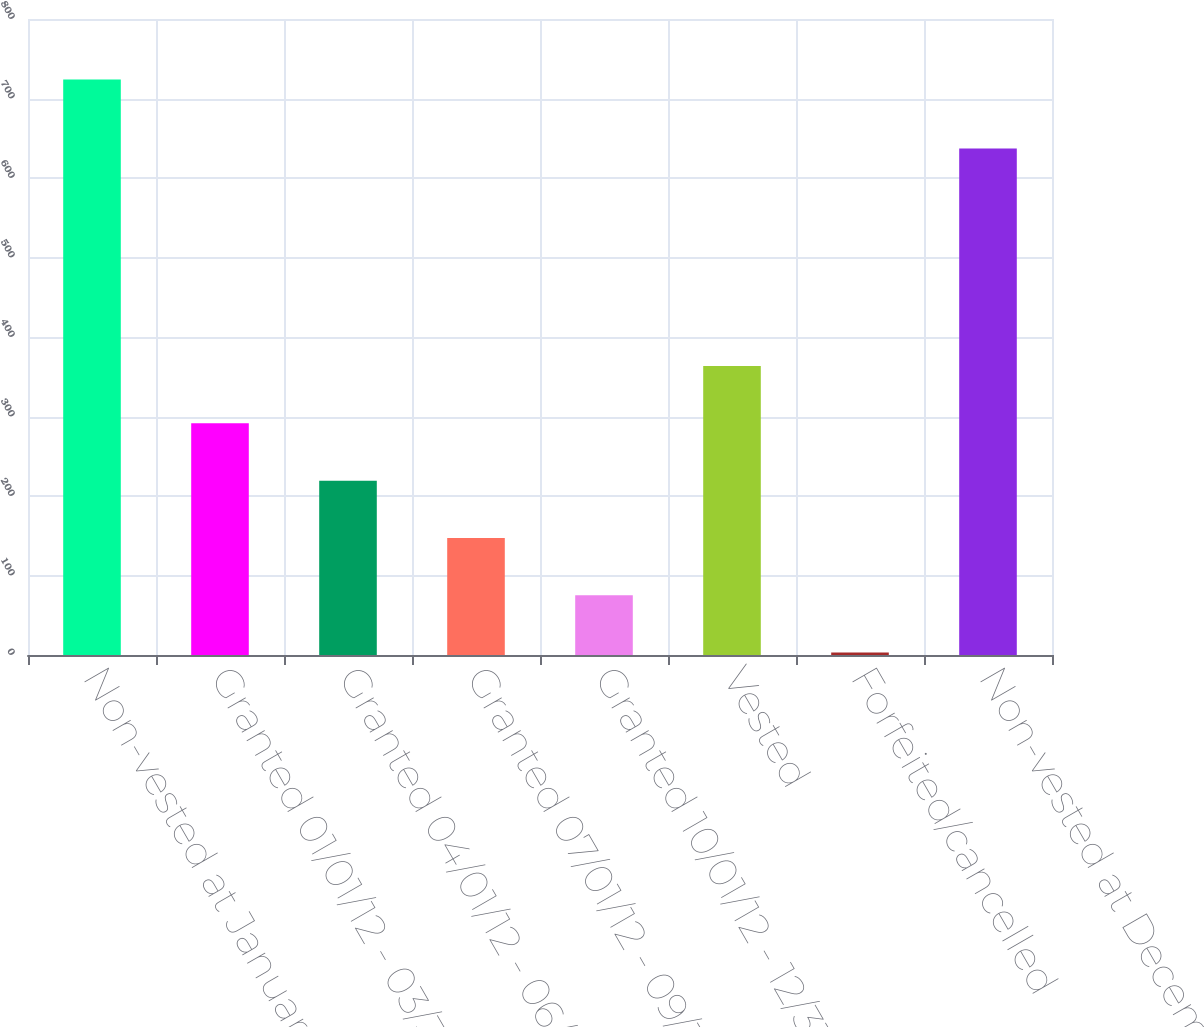Convert chart to OTSL. <chart><loc_0><loc_0><loc_500><loc_500><bar_chart><fcel>Non-vested at January 1 2012<fcel>Granted 01/01/12 - 03/31/12<fcel>Granted 04/01/12 - 06/30/12<fcel>Granted 07/01/12 - 09/30/12<fcel>Granted 10/01/12 - 12/31/12<fcel>Vested<fcel>Forfeited/cancelled<fcel>Non-vested at December 31 2012<nl><fcel>724<fcel>291.4<fcel>219.3<fcel>147.2<fcel>75.1<fcel>363.5<fcel>3<fcel>637<nl></chart> 